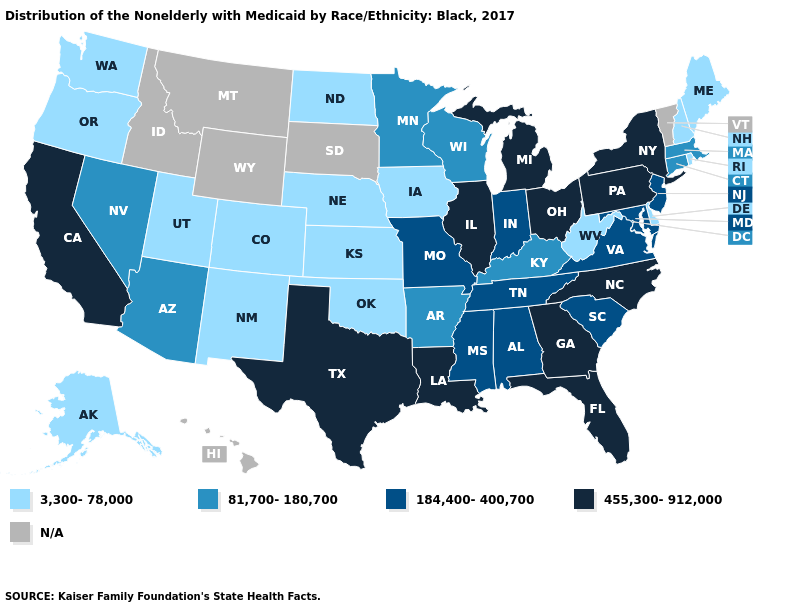How many symbols are there in the legend?
Short answer required. 5. Which states have the lowest value in the USA?
Write a very short answer. Alaska, Colorado, Delaware, Iowa, Kansas, Maine, Nebraska, New Hampshire, New Mexico, North Dakota, Oklahoma, Oregon, Rhode Island, Utah, Washington, West Virginia. Among the states that border Pennsylvania , does Delaware have the lowest value?
Answer briefly. Yes. Does Pennsylvania have the highest value in the USA?
Give a very brief answer. Yes. What is the highest value in the USA?
Keep it brief. 455,300-912,000. How many symbols are there in the legend?
Short answer required. 5. Does Louisiana have the highest value in the South?
Answer briefly. Yes. Among the states that border Georgia , does North Carolina have the lowest value?
Concise answer only. No. What is the lowest value in states that border Nevada?
Keep it brief. 3,300-78,000. What is the value of Ohio?
Quick response, please. 455,300-912,000. Does Maine have the lowest value in the Northeast?
Give a very brief answer. Yes. What is the lowest value in states that border Utah?
Keep it brief. 3,300-78,000. What is the highest value in the USA?
Write a very short answer. 455,300-912,000. What is the lowest value in the MidWest?
Concise answer only. 3,300-78,000. 